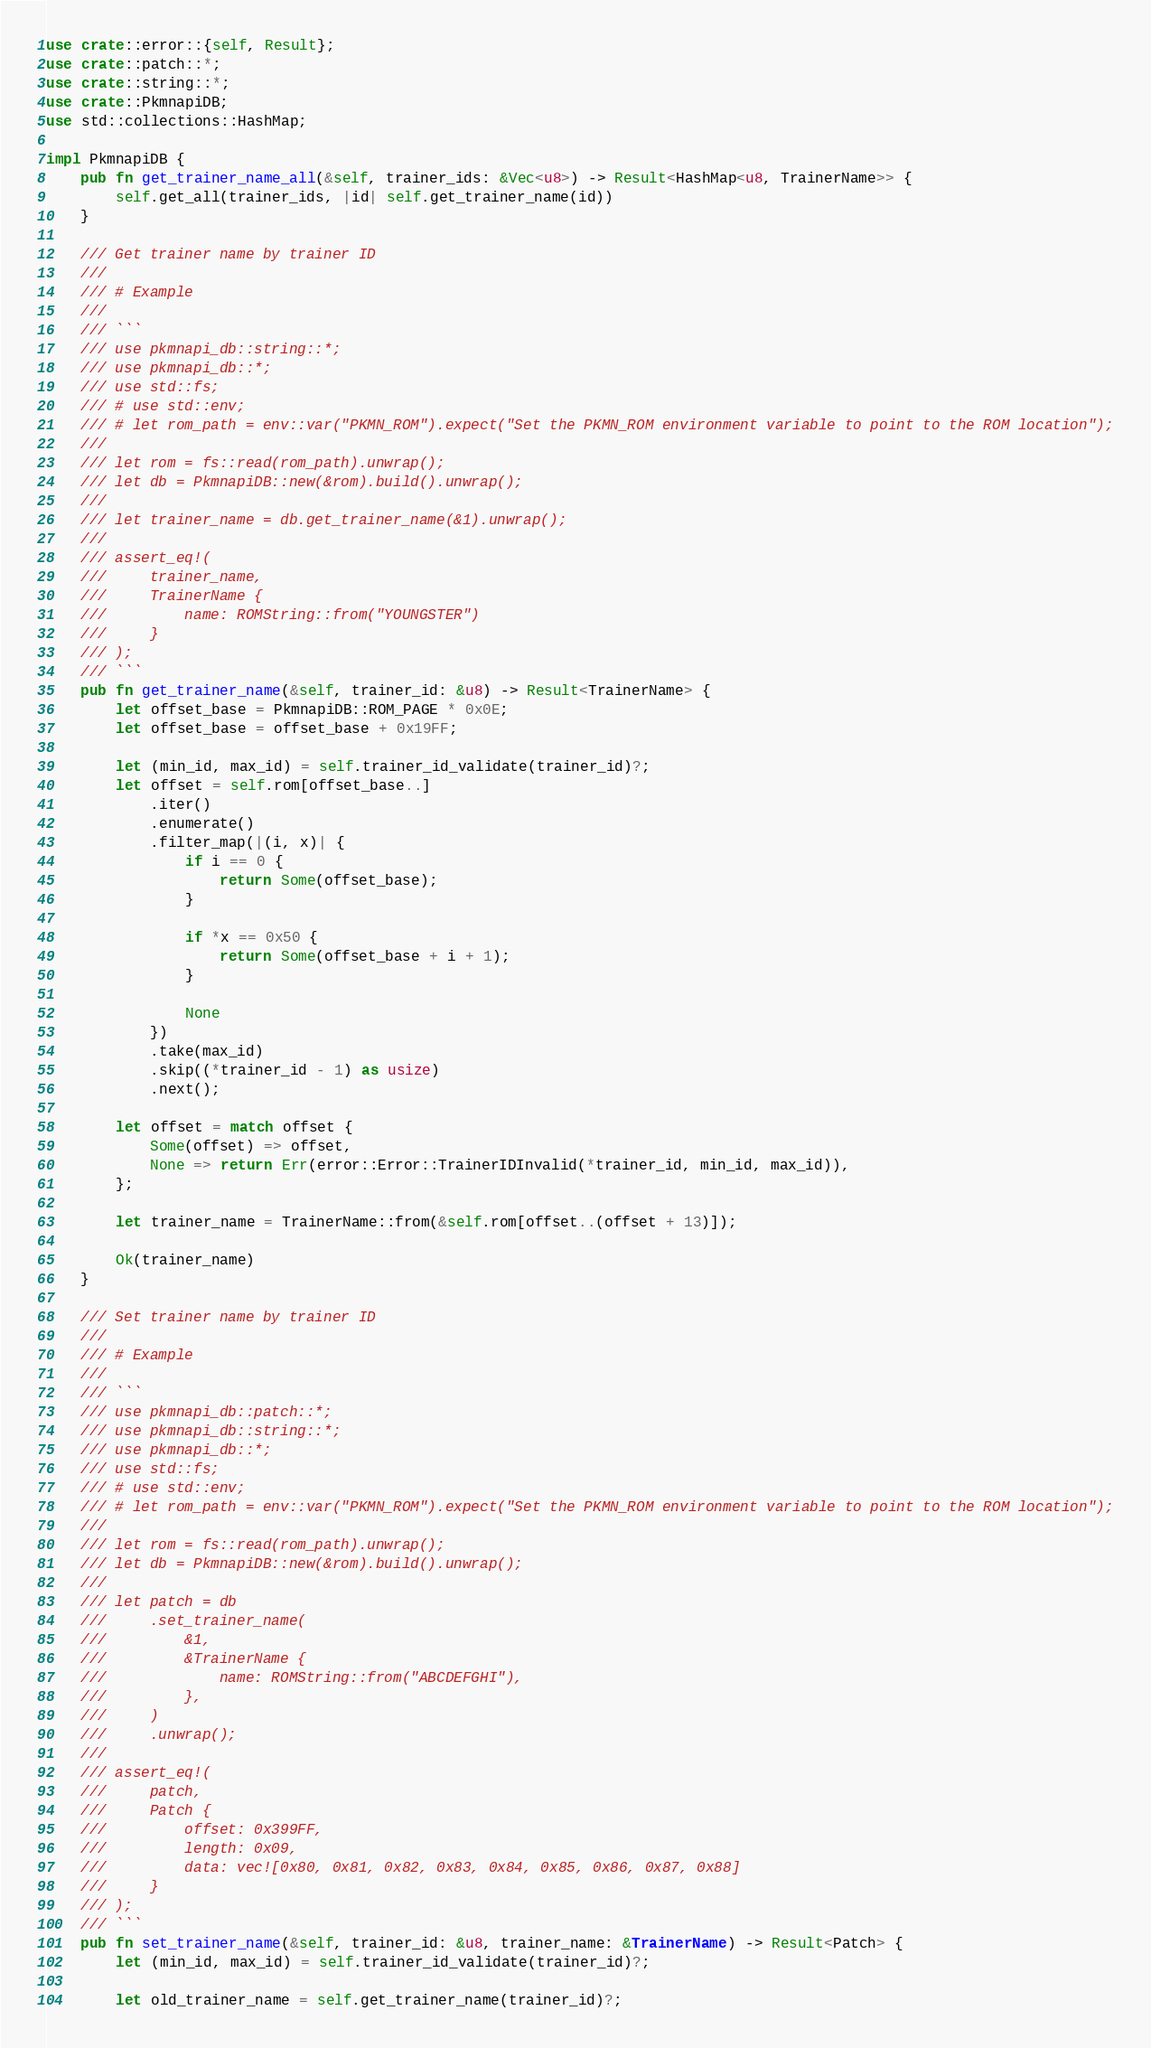<code> <loc_0><loc_0><loc_500><loc_500><_Rust_>use crate::error::{self, Result};
use crate::patch::*;
use crate::string::*;
use crate::PkmnapiDB;
use std::collections::HashMap;

impl PkmnapiDB {
    pub fn get_trainer_name_all(&self, trainer_ids: &Vec<u8>) -> Result<HashMap<u8, TrainerName>> {
        self.get_all(trainer_ids, |id| self.get_trainer_name(id))
    }

    /// Get trainer name by trainer ID
    ///
    /// # Example
    ///
    /// ```
    /// use pkmnapi_db::string::*;
    /// use pkmnapi_db::*;
    /// use std::fs;
    /// # use std::env;
    /// # let rom_path = env::var("PKMN_ROM").expect("Set the PKMN_ROM environment variable to point to the ROM location");
    ///
    /// let rom = fs::read(rom_path).unwrap();
    /// let db = PkmnapiDB::new(&rom).build().unwrap();
    ///
    /// let trainer_name = db.get_trainer_name(&1).unwrap();
    ///
    /// assert_eq!(
    ///     trainer_name,
    ///     TrainerName {
    ///         name: ROMString::from("YOUNGSTER")
    ///     }
    /// );
    /// ```
    pub fn get_trainer_name(&self, trainer_id: &u8) -> Result<TrainerName> {
        let offset_base = PkmnapiDB::ROM_PAGE * 0x0E;
        let offset_base = offset_base + 0x19FF;

        let (min_id, max_id) = self.trainer_id_validate(trainer_id)?;
        let offset = self.rom[offset_base..]
            .iter()
            .enumerate()
            .filter_map(|(i, x)| {
                if i == 0 {
                    return Some(offset_base);
                }

                if *x == 0x50 {
                    return Some(offset_base + i + 1);
                }

                None
            })
            .take(max_id)
            .skip((*trainer_id - 1) as usize)
            .next();

        let offset = match offset {
            Some(offset) => offset,
            None => return Err(error::Error::TrainerIDInvalid(*trainer_id, min_id, max_id)),
        };

        let trainer_name = TrainerName::from(&self.rom[offset..(offset + 13)]);

        Ok(trainer_name)
    }

    /// Set trainer name by trainer ID
    ///
    /// # Example
    ///
    /// ```
    /// use pkmnapi_db::patch::*;
    /// use pkmnapi_db::string::*;
    /// use pkmnapi_db::*;
    /// use std::fs;
    /// # use std::env;
    /// # let rom_path = env::var("PKMN_ROM").expect("Set the PKMN_ROM environment variable to point to the ROM location");
    ///
    /// let rom = fs::read(rom_path).unwrap();
    /// let db = PkmnapiDB::new(&rom).build().unwrap();
    ///
    /// let patch = db
    ///     .set_trainer_name(
    ///         &1,
    ///         &TrainerName {
    ///             name: ROMString::from("ABCDEFGHI"),
    ///         },
    ///     )
    ///     .unwrap();
    ///
    /// assert_eq!(
    ///     patch,
    ///     Patch {
    ///         offset: 0x399FF,
    ///         length: 0x09,
    ///         data: vec![0x80, 0x81, 0x82, 0x83, 0x84, 0x85, 0x86, 0x87, 0x88]
    ///     }
    /// );
    /// ```
    pub fn set_trainer_name(&self, trainer_id: &u8, trainer_name: &TrainerName) -> Result<Patch> {
        let (min_id, max_id) = self.trainer_id_validate(trainer_id)?;

        let old_trainer_name = self.get_trainer_name(trainer_id)?;</code> 